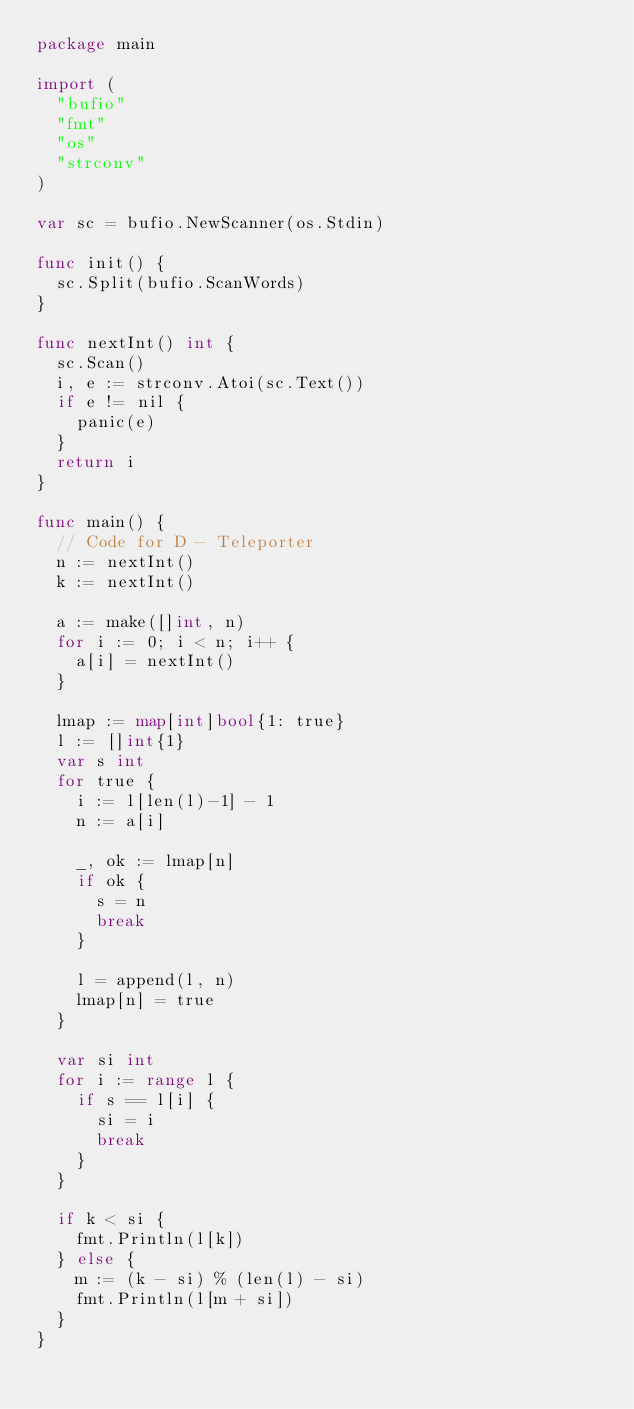<code> <loc_0><loc_0><loc_500><loc_500><_Go_>package main

import (
	"bufio"
	"fmt"
	"os"
	"strconv"
)

var sc = bufio.NewScanner(os.Stdin)

func init() {
	sc.Split(bufio.ScanWords)
}

func nextInt() int {
	sc.Scan()
	i, e := strconv.Atoi(sc.Text())
	if e != nil {
		panic(e)
	}
	return i
}

func main() {
	// Code for D - Teleporter
	n := nextInt()
	k := nextInt()

	a := make([]int, n)
	for i := 0; i < n; i++ {
		a[i] = nextInt()
	}

	lmap := map[int]bool{1: true}
	l := []int{1}
	var s int
	for true {
		i := l[len(l)-1] - 1
		n := a[i]

		_, ok := lmap[n]
		if ok {
			s = n
			break
		}

		l = append(l, n)
		lmap[n] = true
	}

	var si int
	for i := range l {
		if s == l[i] {
			si = i
			break
		}
	}

	if k < si {
		fmt.Println(l[k])
	} else {
		m := (k - si) % (len(l) - si)
		fmt.Println(l[m + si])
	}
}
</code> 